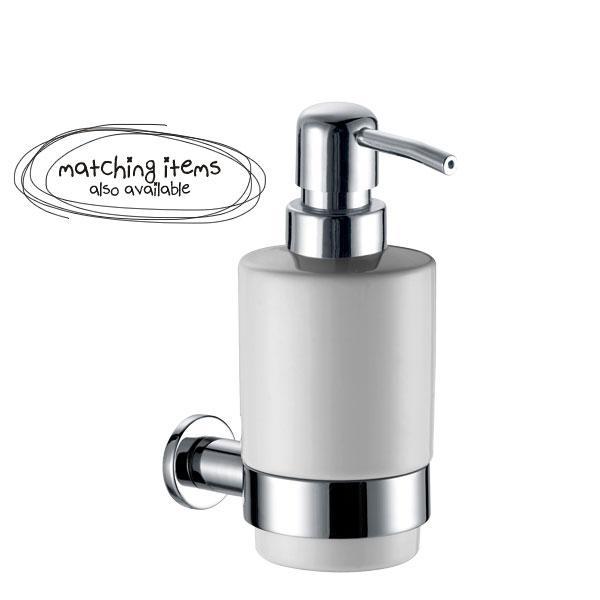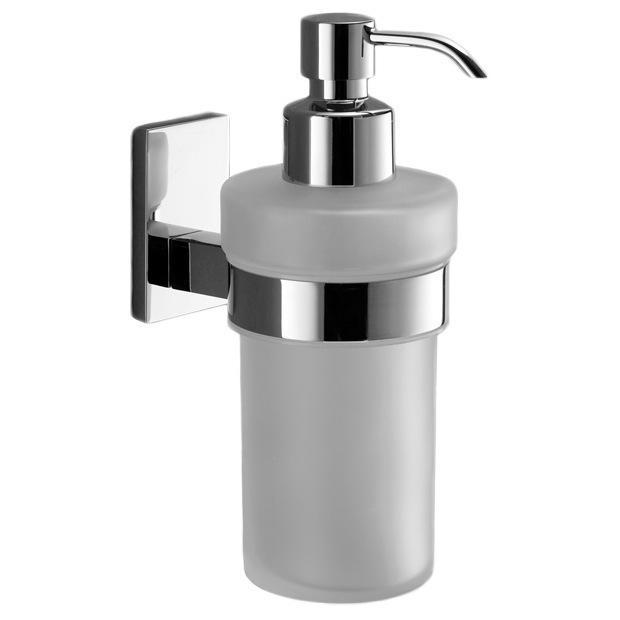The first image is the image on the left, the second image is the image on the right. Analyze the images presented: Is the assertion "Each image contains one cylindrical pump-top dispenser that mounts alone on a wall and has a chrome top and narrow band around it." valid? Answer yes or no. Yes. The first image is the image on the left, the second image is the image on the right. Analyze the images presented: Is the assertion "The left and right image contains the same number of wall hanging soap dispensers." valid? Answer yes or no. Yes. 